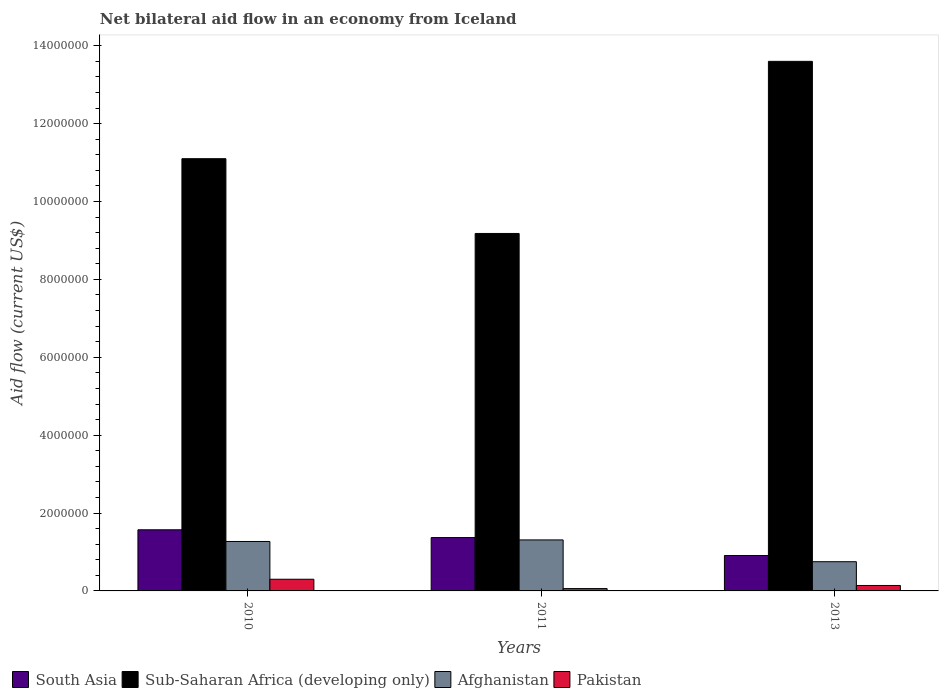How many groups of bars are there?
Your answer should be compact. 3. Are the number of bars per tick equal to the number of legend labels?
Ensure brevity in your answer.  Yes. Are the number of bars on each tick of the X-axis equal?
Make the answer very short. Yes. How many bars are there on the 1st tick from the left?
Ensure brevity in your answer.  4. What is the net bilateral aid flow in Afghanistan in 2011?
Give a very brief answer. 1.31e+06. What is the total net bilateral aid flow in Sub-Saharan Africa (developing only) in the graph?
Give a very brief answer. 3.39e+07. What is the difference between the net bilateral aid flow in Afghanistan in 2011 and that in 2013?
Ensure brevity in your answer.  5.60e+05. What is the difference between the net bilateral aid flow in South Asia in 2010 and the net bilateral aid flow in Afghanistan in 2013?
Make the answer very short. 8.20e+05. What is the average net bilateral aid flow in Pakistan per year?
Your response must be concise. 1.67e+05. What is the ratio of the net bilateral aid flow in Sub-Saharan Africa (developing only) in 2010 to that in 2013?
Your response must be concise. 0.82. Is the difference between the net bilateral aid flow in Afghanistan in 2010 and 2013 greater than the difference between the net bilateral aid flow in South Asia in 2010 and 2013?
Your answer should be compact. No. What is the difference between the highest and the lowest net bilateral aid flow in Afghanistan?
Provide a short and direct response. 5.60e+05. Is the sum of the net bilateral aid flow in Afghanistan in 2011 and 2013 greater than the maximum net bilateral aid flow in Pakistan across all years?
Provide a short and direct response. Yes. Is it the case that in every year, the sum of the net bilateral aid flow in Afghanistan and net bilateral aid flow in Sub-Saharan Africa (developing only) is greater than the sum of net bilateral aid flow in Pakistan and net bilateral aid flow in South Asia?
Offer a very short reply. Yes. What does the 3rd bar from the left in 2010 represents?
Give a very brief answer. Afghanistan. What does the 4th bar from the right in 2010 represents?
Give a very brief answer. South Asia. Is it the case that in every year, the sum of the net bilateral aid flow in Pakistan and net bilateral aid flow in Sub-Saharan Africa (developing only) is greater than the net bilateral aid flow in Afghanistan?
Offer a very short reply. Yes. Does the graph contain grids?
Make the answer very short. No. How many legend labels are there?
Give a very brief answer. 4. How are the legend labels stacked?
Provide a succinct answer. Horizontal. What is the title of the graph?
Keep it short and to the point. Net bilateral aid flow in an economy from Iceland. Does "Papua New Guinea" appear as one of the legend labels in the graph?
Your answer should be compact. No. What is the label or title of the X-axis?
Make the answer very short. Years. What is the Aid flow (current US$) in South Asia in 2010?
Keep it short and to the point. 1.57e+06. What is the Aid flow (current US$) in Sub-Saharan Africa (developing only) in 2010?
Give a very brief answer. 1.11e+07. What is the Aid flow (current US$) in Afghanistan in 2010?
Provide a succinct answer. 1.27e+06. What is the Aid flow (current US$) of South Asia in 2011?
Give a very brief answer. 1.37e+06. What is the Aid flow (current US$) of Sub-Saharan Africa (developing only) in 2011?
Provide a short and direct response. 9.18e+06. What is the Aid flow (current US$) in Afghanistan in 2011?
Provide a succinct answer. 1.31e+06. What is the Aid flow (current US$) in Pakistan in 2011?
Provide a succinct answer. 6.00e+04. What is the Aid flow (current US$) of South Asia in 2013?
Give a very brief answer. 9.10e+05. What is the Aid flow (current US$) of Sub-Saharan Africa (developing only) in 2013?
Keep it short and to the point. 1.36e+07. What is the Aid flow (current US$) in Afghanistan in 2013?
Your answer should be compact. 7.50e+05. Across all years, what is the maximum Aid flow (current US$) in South Asia?
Offer a terse response. 1.57e+06. Across all years, what is the maximum Aid flow (current US$) in Sub-Saharan Africa (developing only)?
Provide a succinct answer. 1.36e+07. Across all years, what is the maximum Aid flow (current US$) in Afghanistan?
Make the answer very short. 1.31e+06. Across all years, what is the maximum Aid flow (current US$) in Pakistan?
Offer a terse response. 3.00e+05. Across all years, what is the minimum Aid flow (current US$) in South Asia?
Give a very brief answer. 9.10e+05. Across all years, what is the minimum Aid flow (current US$) of Sub-Saharan Africa (developing only)?
Keep it short and to the point. 9.18e+06. Across all years, what is the minimum Aid flow (current US$) of Afghanistan?
Your answer should be compact. 7.50e+05. What is the total Aid flow (current US$) in South Asia in the graph?
Keep it short and to the point. 3.85e+06. What is the total Aid flow (current US$) in Sub-Saharan Africa (developing only) in the graph?
Your answer should be compact. 3.39e+07. What is the total Aid flow (current US$) in Afghanistan in the graph?
Your answer should be compact. 3.33e+06. What is the total Aid flow (current US$) of Pakistan in the graph?
Make the answer very short. 5.00e+05. What is the difference between the Aid flow (current US$) of Sub-Saharan Africa (developing only) in 2010 and that in 2011?
Offer a terse response. 1.92e+06. What is the difference between the Aid flow (current US$) of Afghanistan in 2010 and that in 2011?
Give a very brief answer. -4.00e+04. What is the difference between the Aid flow (current US$) of South Asia in 2010 and that in 2013?
Provide a short and direct response. 6.60e+05. What is the difference between the Aid flow (current US$) in Sub-Saharan Africa (developing only) in 2010 and that in 2013?
Your answer should be very brief. -2.50e+06. What is the difference between the Aid flow (current US$) in Afghanistan in 2010 and that in 2013?
Your answer should be very brief. 5.20e+05. What is the difference between the Aid flow (current US$) of Sub-Saharan Africa (developing only) in 2011 and that in 2013?
Offer a very short reply. -4.42e+06. What is the difference between the Aid flow (current US$) of Afghanistan in 2011 and that in 2013?
Offer a very short reply. 5.60e+05. What is the difference between the Aid flow (current US$) in Pakistan in 2011 and that in 2013?
Offer a very short reply. -8.00e+04. What is the difference between the Aid flow (current US$) in South Asia in 2010 and the Aid flow (current US$) in Sub-Saharan Africa (developing only) in 2011?
Give a very brief answer. -7.61e+06. What is the difference between the Aid flow (current US$) of South Asia in 2010 and the Aid flow (current US$) of Afghanistan in 2011?
Offer a very short reply. 2.60e+05. What is the difference between the Aid flow (current US$) in South Asia in 2010 and the Aid flow (current US$) in Pakistan in 2011?
Make the answer very short. 1.51e+06. What is the difference between the Aid flow (current US$) in Sub-Saharan Africa (developing only) in 2010 and the Aid flow (current US$) in Afghanistan in 2011?
Offer a very short reply. 9.79e+06. What is the difference between the Aid flow (current US$) in Sub-Saharan Africa (developing only) in 2010 and the Aid flow (current US$) in Pakistan in 2011?
Keep it short and to the point. 1.10e+07. What is the difference between the Aid flow (current US$) of Afghanistan in 2010 and the Aid flow (current US$) of Pakistan in 2011?
Give a very brief answer. 1.21e+06. What is the difference between the Aid flow (current US$) in South Asia in 2010 and the Aid flow (current US$) in Sub-Saharan Africa (developing only) in 2013?
Provide a short and direct response. -1.20e+07. What is the difference between the Aid flow (current US$) in South Asia in 2010 and the Aid flow (current US$) in Afghanistan in 2013?
Give a very brief answer. 8.20e+05. What is the difference between the Aid flow (current US$) of South Asia in 2010 and the Aid flow (current US$) of Pakistan in 2013?
Your response must be concise. 1.43e+06. What is the difference between the Aid flow (current US$) in Sub-Saharan Africa (developing only) in 2010 and the Aid flow (current US$) in Afghanistan in 2013?
Your answer should be very brief. 1.04e+07. What is the difference between the Aid flow (current US$) of Sub-Saharan Africa (developing only) in 2010 and the Aid flow (current US$) of Pakistan in 2013?
Make the answer very short. 1.10e+07. What is the difference between the Aid flow (current US$) in Afghanistan in 2010 and the Aid flow (current US$) in Pakistan in 2013?
Provide a short and direct response. 1.13e+06. What is the difference between the Aid flow (current US$) in South Asia in 2011 and the Aid flow (current US$) in Sub-Saharan Africa (developing only) in 2013?
Give a very brief answer. -1.22e+07. What is the difference between the Aid flow (current US$) in South Asia in 2011 and the Aid flow (current US$) in Afghanistan in 2013?
Offer a terse response. 6.20e+05. What is the difference between the Aid flow (current US$) in South Asia in 2011 and the Aid flow (current US$) in Pakistan in 2013?
Your answer should be very brief. 1.23e+06. What is the difference between the Aid flow (current US$) of Sub-Saharan Africa (developing only) in 2011 and the Aid flow (current US$) of Afghanistan in 2013?
Your response must be concise. 8.43e+06. What is the difference between the Aid flow (current US$) of Sub-Saharan Africa (developing only) in 2011 and the Aid flow (current US$) of Pakistan in 2013?
Keep it short and to the point. 9.04e+06. What is the difference between the Aid flow (current US$) of Afghanistan in 2011 and the Aid flow (current US$) of Pakistan in 2013?
Provide a succinct answer. 1.17e+06. What is the average Aid flow (current US$) of South Asia per year?
Ensure brevity in your answer.  1.28e+06. What is the average Aid flow (current US$) of Sub-Saharan Africa (developing only) per year?
Provide a succinct answer. 1.13e+07. What is the average Aid flow (current US$) of Afghanistan per year?
Your answer should be compact. 1.11e+06. What is the average Aid flow (current US$) in Pakistan per year?
Offer a very short reply. 1.67e+05. In the year 2010, what is the difference between the Aid flow (current US$) in South Asia and Aid flow (current US$) in Sub-Saharan Africa (developing only)?
Ensure brevity in your answer.  -9.53e+06. In the year 2010, what is the difference between the Aid flow (current US$) in South Asia and Aid flow (current US$) in Afghanistan?
Provide a short and direct response. 3.00e+05. In the year 2010, what is the difference between the Aid flow (current US$) of South Asia and Aid flow (current US$) of Pakistan?
Make the answer very short. 1.27e+06. In the year 2010, what is the difference between the Aid flow (current US$) in Sub-Saharan Africa (developing only) and Aid flow (current US$) in Afghanistan?
Provide a succinct answer. 9.83e+06. In the year 2010, what is the difference between the Aid flow (current US$) of Sub-Saharan Africa (developing only) and Aid flow (current US$) of Pakistan?
Offer a terse response. 1.08e+07. In the year 2010, what is the difference between the Aid flow (current US$) in Afghanistan and Aid flow (current US$) in Pakistan?
Give a very brief answer. 9.70e+05. In the year 2011, what is the difference between the Aid flow (current US$) of South Asia and Aid flow (current US$) of Sub-Saharan Africa (developing only)?
Make the answer very short. -7.81e+06. In the year 2011, what is the difference between the Aid flow (current US$) of South Asia and Aid flow (current US$) of Afghanistan?
Keep it short and to the point. 6.00e+04. In the year 2011, what is the difference between the Aid flow (current US$) in South Asia and Aid flow (current US$) in Pakistan?
Your answer should be very brief. 1.31e+06. In the year 2011, what is the difference between the Aid flow (current US$) in Sub-Saharan Africa (developing only) and Aid flow (current US$) in Afghanistan?
Your response must be concise. 7.87e+06. In the year 2011, what is the difference between the Aid flow (current US$) in Sub-Saharan Africa (developing only) and Aid flow (current US$) in Pakistan?
Give a very brief answer. 9.12e+06. In the year 2011, what is the difference between the Aid flow (current US$) in Afghanistan and Aid flow (current US$) in Pakistan?
Provide a short and direct response. 1.25e+06. In the year 2013, what is the difference between the Aid flow (current US$) of South Asia and Aid flow (current US$) of Sub-Saharan Africa (developing only)?
Ensure brevity in your answer.  -1.27e+07. In the year 2013, what is the difference between the Aid flow (current US$) of South Asia and Aid flow (current US$) of Afghanistan?
Ensure brevity in your answer.  1.60e+05. In the year 2013, what is the difference between the Aid flow (current US$) in South Asia and Aid flow (current US$) in Pakistan?
Provide a succinct answer. 7.70e+05. In the year 2013, what is the difference between the Aid flow (current US$) of Sub-Saharan Africa (developing only) and Aid flow (current US$) of Afghanistan?
Your answer should be very brief. 1.28e+07. In the year 2013, what is the difference between the Aid flow (current US$) of Sub-Saharan Africa (developing only) and Aid flow (current US$) of Pakistan?
Offer a very short reply. 1.35e+07. In the year 2013, what is the difference between the Aid flow (current US$) of Afghanistan and Aid flow (current US$) of Pakistan?
Ensure brevity in your answer.  6.10e+05. What is the ratio of the Aid flow (current US$) of South Asia in 2010 to that in 2011?
Your answer should be compact. 1.15. What is the ratio of the Aid flow (current US$) of Sub-Saharan Africa (developing only) in 2010 to that in 2011?
Keep it short and to the point. 1.21. What is the ratio of the Aid flow (current US$) of Afghanistan in 2010 to that in 2011?
Your response must be concise. 0.97. What is the ratio of the Aid flow (current US$) in South Asia in 2010 to that in 2013?
Your answer should be compact. 1.73. What is the ratio of the Aid flow (current US$) of Sub-Saharan Africa (developing only) in 2010 to that in 2013?
Keep it short and to the point. 0.82. What is the ratio of the Aid flow (current US$) in Afghanistan in 2010 to that in 2013?
Offer a very short reply. 1.69. What is the ratio of the Aid flow (current US$) of Pakistan in 2010 to that in 2013?
Provide a succinct answer. 2.14. What is the ratio of the Aid flow (current US$) in South Asia in 2011 to that in 2013?
Your answer should be compact. 1.51. What is the ratio of the Aid flow (current US$) of Sub-Saharan Africa (developing only) in 2011 to that in 2013?
Offer a very short reply. 0.68. What is the ratio of the Aid flow (current US$) of Afghanistan in 2011 to that in 2013?
Provide a short and direct response. 1.75. What is the ratio of the Aid flow (current US$) in Pakistan in 2011 to that in 2013?
Offer a terse response. 0.43. What is the difference between the highest and the second highest Aid flow (current US$) of South Asia?
Ensure brevity in your answer.  2.00e+05. What is the difference between the highest and the second highest Aid flow (current US$) in Sub-Saharan Africa (developing only)?
Offer a very short reply. 2.50e+06. What is the difference between the highest and the second highest Aid flow (current US$) in Afghanistan?
Offer a very short reply. 4.00e+04. What is the difference between the highest and the second highest Aid flow (current US$) of Pakistan?
Provide a short and direct response. 1.60e+05. What is the difference between the highest and the lowest Aid flow (current US$) of South Asia?
Your answer should be very brief. 6.60e+05. What is the difference between the highest and the lowest Aid flow (current US$) of Sub-Saharan Africa (developing only)?
Offer a very short reply. 4.42e+06. What is the difference between the highest and the lowest Aid flow (current US$) in Afghanistan?
Give a very brief answer. 5.60e+05. 